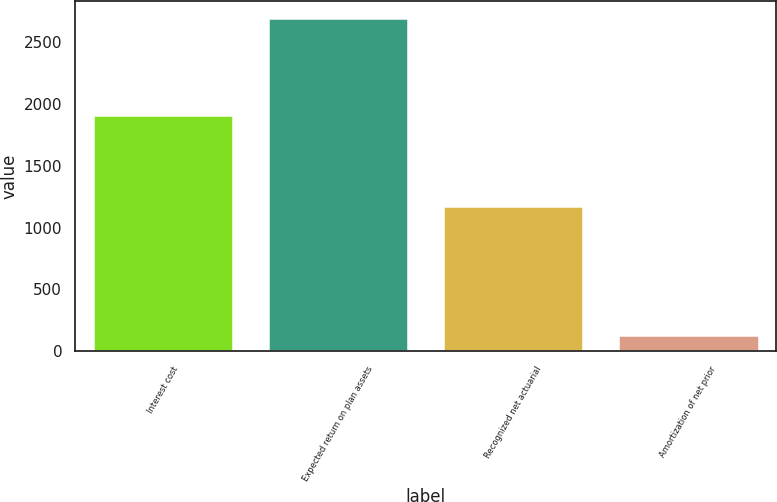Convert chart. <chart><loc_0><loc_0><loc_500><loc_500><bar_chart><fcel>Interest cost<fcel>Expected return on plan assets<fcel>Recognized net actuarial<fcel>Amortization of net prior<nl><fcel>1912<fcel>2693<fcel>1173<fcel>134<nl></chart> 